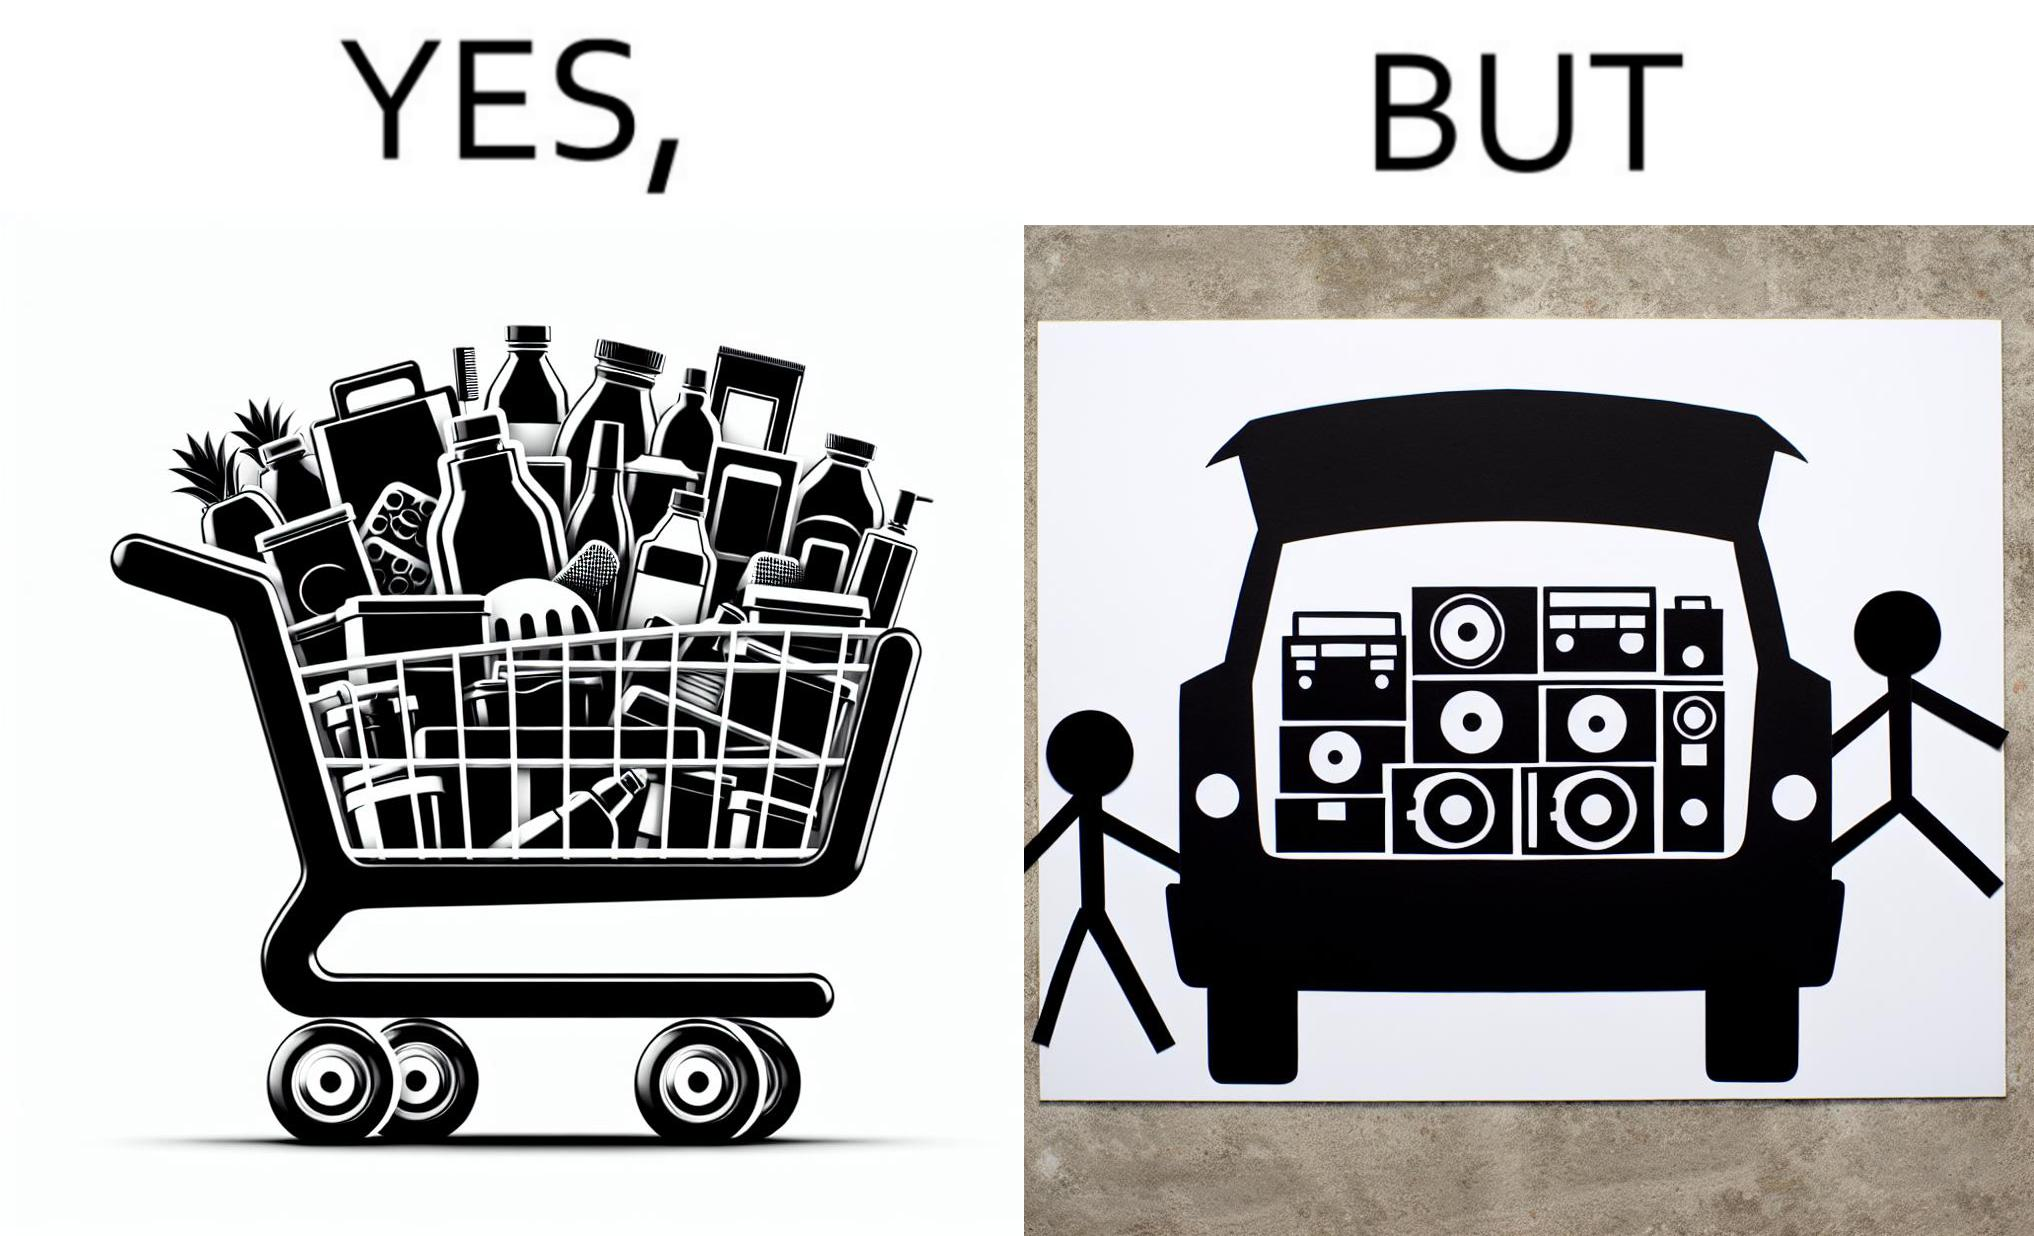Explain why this image is satirical. The image is ironic, because a car trunk was earlier designed to keep some extra luggage or things but people nowadays get speakers installed in the trunk which in turn reduces the space in the trunk and making it difficult for people to store the extra luggage in the trunk 